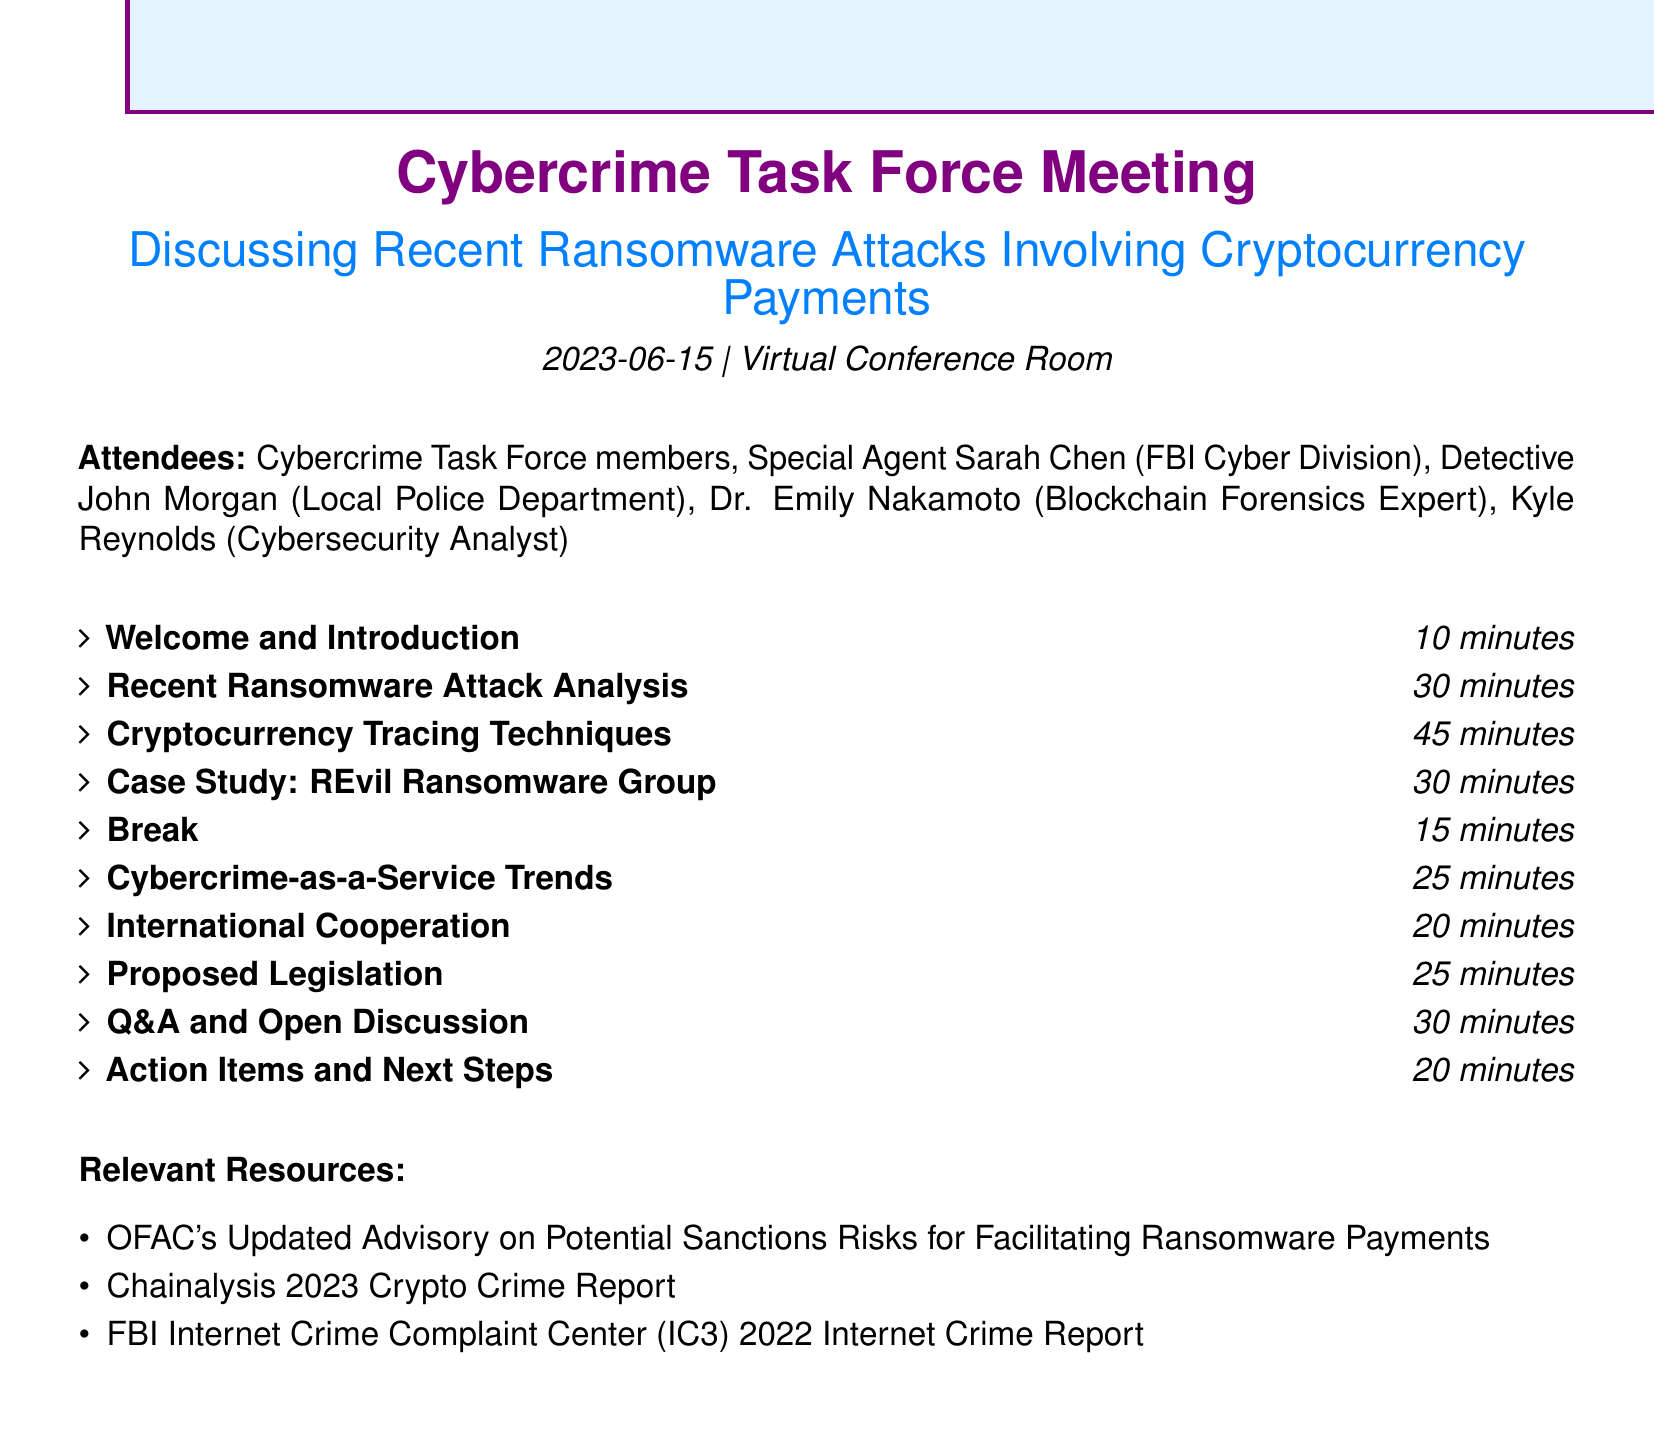What is the date of the meeting? The date of the meeting is mentioned directly in the document under the heading for the meeting information.
Answer: 2023-06-15 Who will present on cryptocurrency tracing techniques? The document specifies that Dr. Emily Nakamoto is the one who will present on this topic during the meeting.
Answer: Dr. Emily Nakamoto How long is the break scheduled for? The break duration is explicitly listed in the agenda as part of the meeting's schedule.
Answer: 15 minutes What was the payment amount in the Colonial Pipeline ransomware attack? The document provides a specific number related to the cryptocurrency payment made during the attack.
Answer: $4.4 million What is one cryptocurrency that the REvil ransomware group prefers? The document mentions the specific cryptocurrency that the REvil group favors during the discussion segment, highlighting its challenges for law enforcement.
Answer: Monero What is the title of the proposed legislation discussed? The title of the proposed legislation is given in the agenda section of the document.
Answer: Ransom Disclosure Act Who is presenting on Cybercrime-as-a-Service trends? The agenda points to a specific individual presenting on this topic, which can be found directly in the meeting details.
Answer: Kyle Reynolds How many minutes are allocated for international cooperation discussion? The document typically allocates a specific duration for each agenda item which includes this discussion topic.
Answer: 20 minutes 